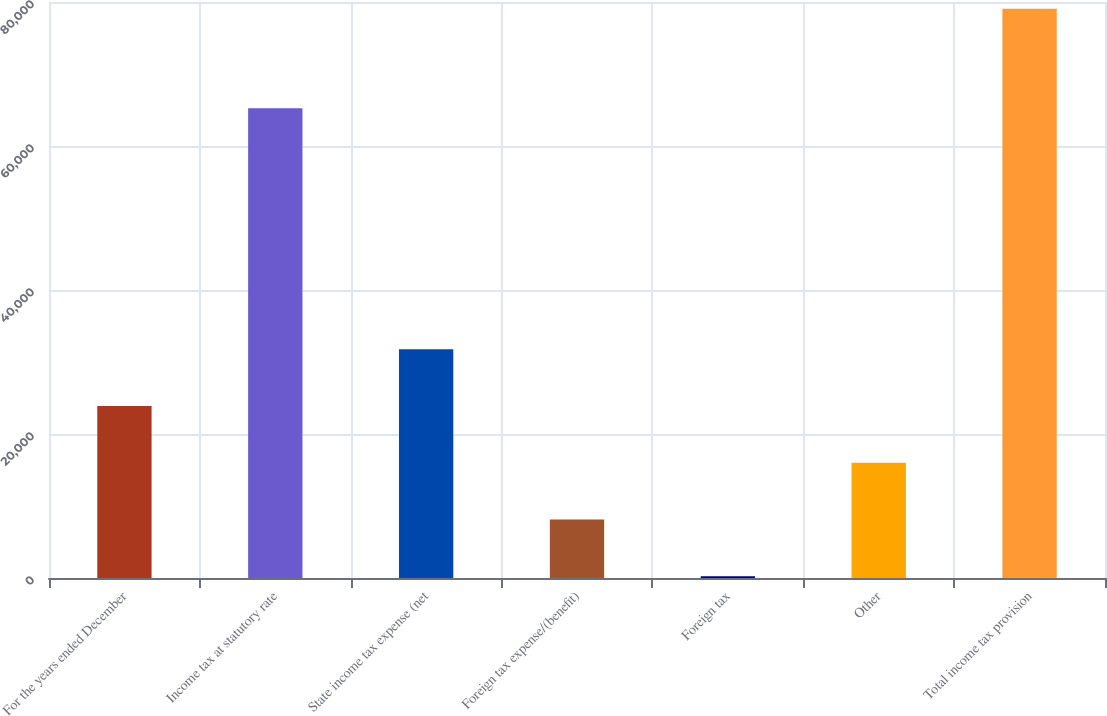Convert chart. <chart><loc_0><loc_0><loc_500><loc_500><bar_chart><fcel>For the years ended December<fcel>Income tax at statutory rate<fcel>State income tax expense (net<fcel>Foreign tax expense/(benefit)<fcel>Foreign tax<fcel>Other<fcel>Total income tax provision<nl><fcel>23884.8<fcel>65254<fcel>31768.4<fcel>8117.6<fcel>234<fcel>16001.2<fcel>79070<nl></chart> 